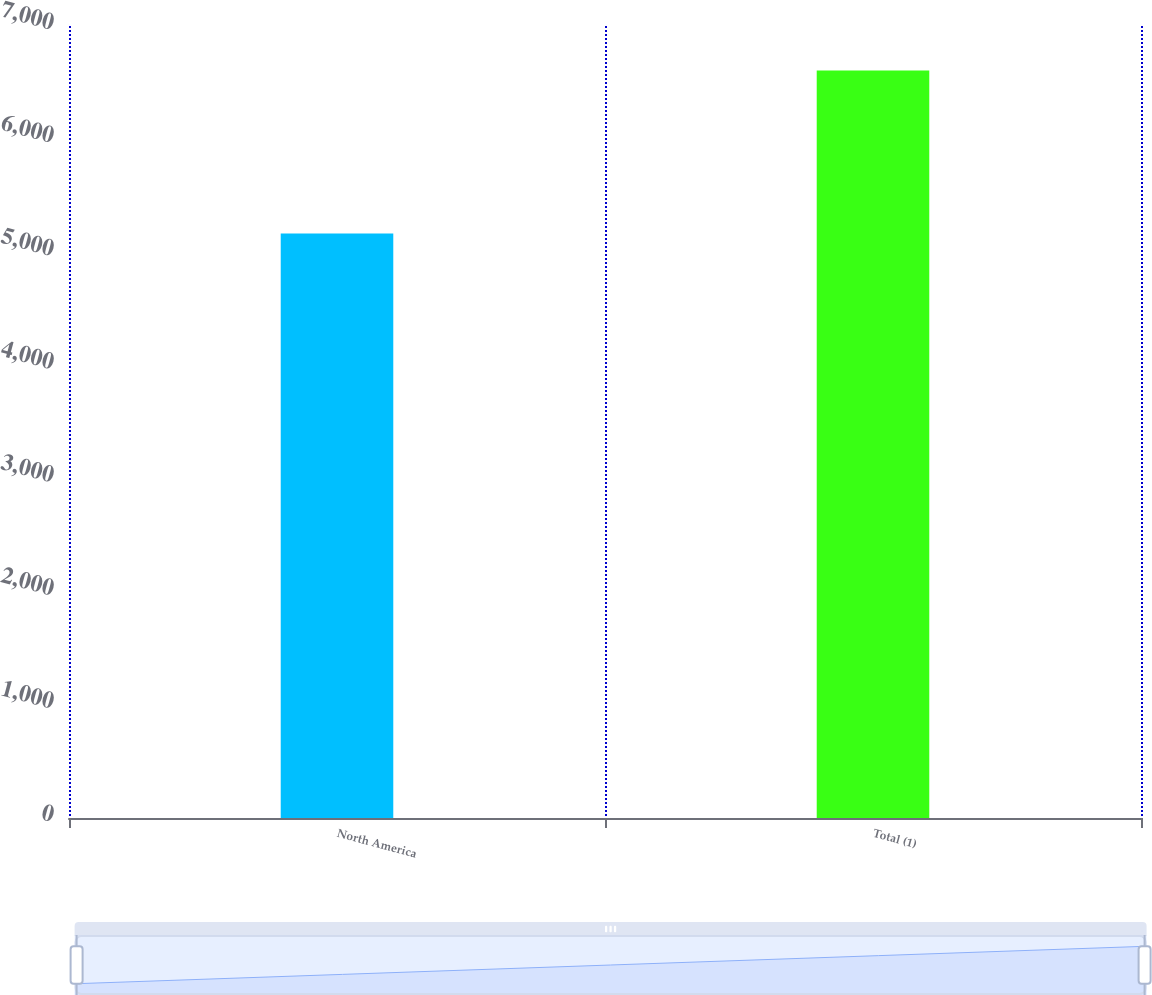<chart> <loc_0><loc_0><loc_500><loc_500><bar_chart><fcel>North America<fcel>Total (1)<nl><fcel>5166.6<fcel>6606<nl></chart> 